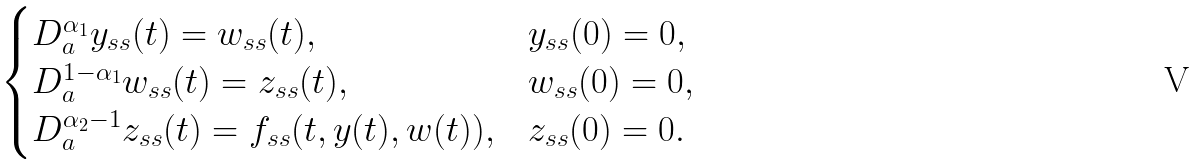<formula> <loc_0><loc_0><loc_500><loc_500>\begin{cases} D ^ { \alpha _ { 1 } } _ { a } y _ { s s } ( t ) = w _ { s s } ( t ) , & y _ { s s } ( 0 ) = 0 , \\ D ^ { 1 - \alpha _ { 1 } } _ { a } w _ { s s } ( t ) = z _ { s s } ( t ) , & w _ { s s } ( 0 ) = 0 , \\ D ^ { \alpha _ { 2 } - 1 } _ { a } z _ { s s } ( t ) = f _ { s s } ( t , y ( t ) , w ( t ) ) , & z _ { s s } ( 0 ) = 0 . \end{cases}</formula> 